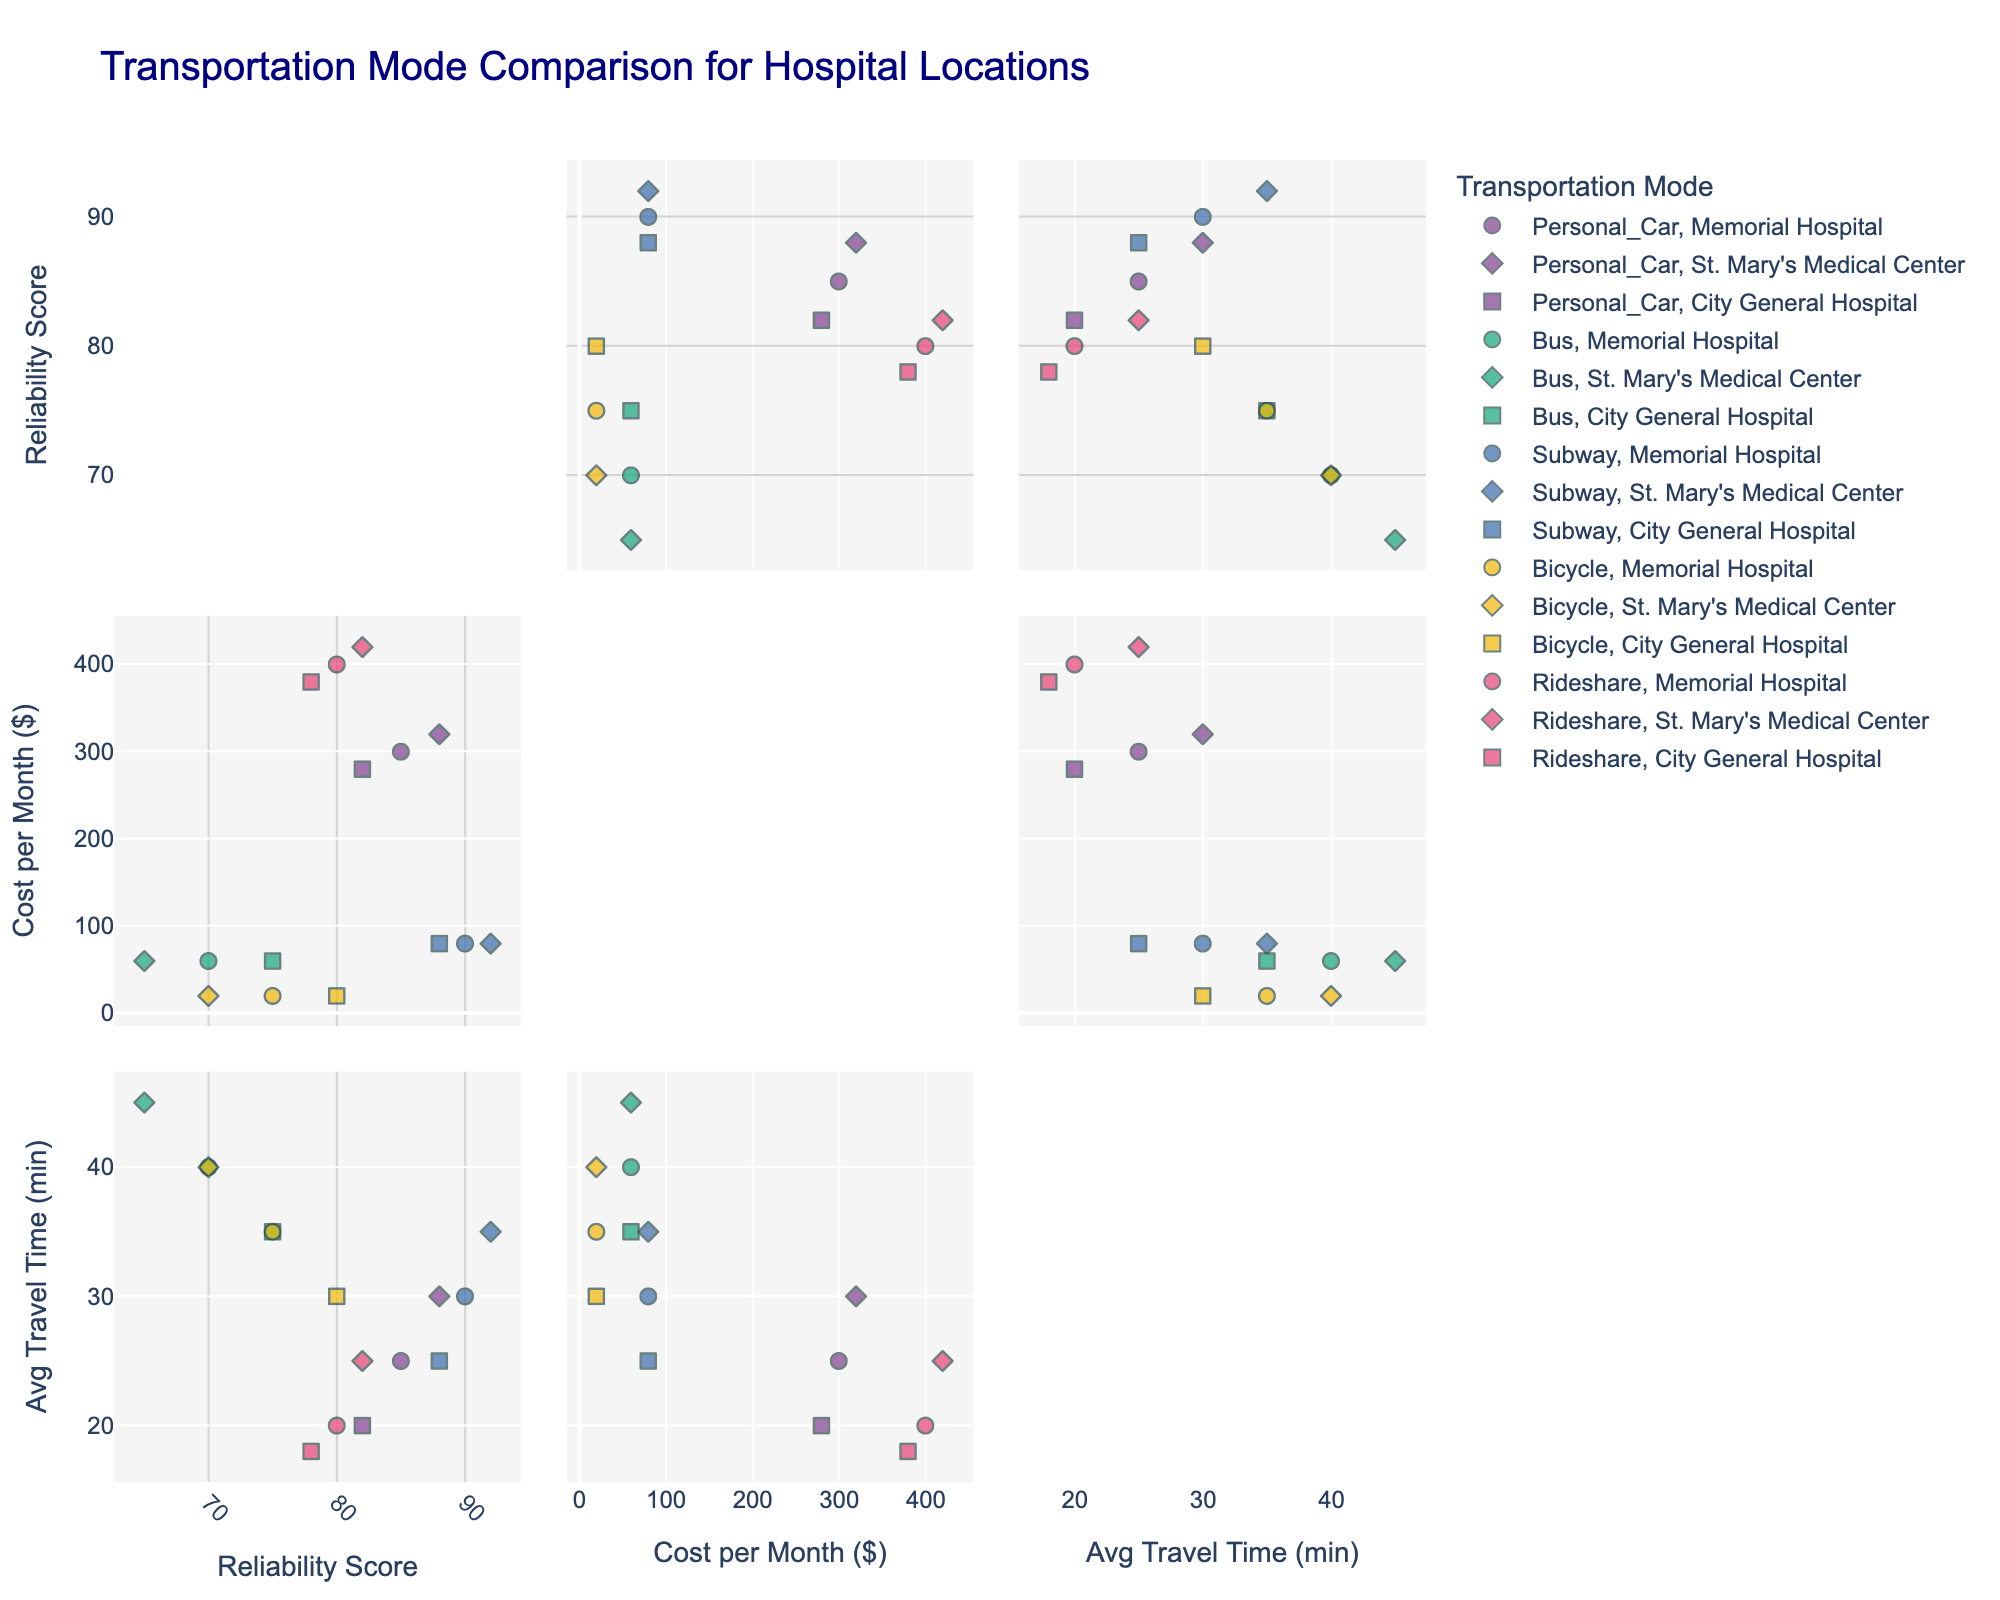What is the title of the scatterplot matrix? The title is displayed at the top of the scatterplot matrix, indicating the main subject of the visualized data.
Answer: Transportation Mode Comparison for Hospital Locations How many different transportation modes are represented in the plot? The legend on the plot shows the different transportation modes that are being compared.
Answer: 5 Which transportation mode has the highest average reliability score at Memorial Hospital? Look at the scatter points for Memorial Hospital and compare the reliability scores.
Answer: Subway What is the cost difference per month between using a personal car and using the subway at City General Hospital? Find the cost points for personal car and subway at City General Hospital, and calculate the difference in their cost.
Answer: $200 Which hospital location generally has the shortest average travel times across all transportation modes? Compare the average travel times for all transportation modes across all hospital locations.
Answer: City General Hospital In which hospital location does the bus have the highest reliability score? Identify the reliability scores of the bus for all hospital locations and determine the highest one.
Answer: City General Hospital For St. Mary’s Medical Center, what is the range of average travel times across different transportation modes? Find the minimum and maximum average travel times for all transportation modes at St. Mary’s Medical Center and calculate the range.
Answer: 20 minutes How does the cost of using rideshare compare to using a personal car at Memorial Hospital? Compare the cost per month for rideshare and personal car at Memorial Hospital.
Answer: Rideshare is $100 more expensive Does any transportation mode have a perfect reliability score (100) at any hospital location? Check all the reliability scores in the scatterplot to see if any mode has a score of 100.
Answer: No What is the average reliability score of the subway across all hospital locations? Find the reliability score of the subway for each hospital location, sum them, and divide by the number of locations.
Answer: 90 